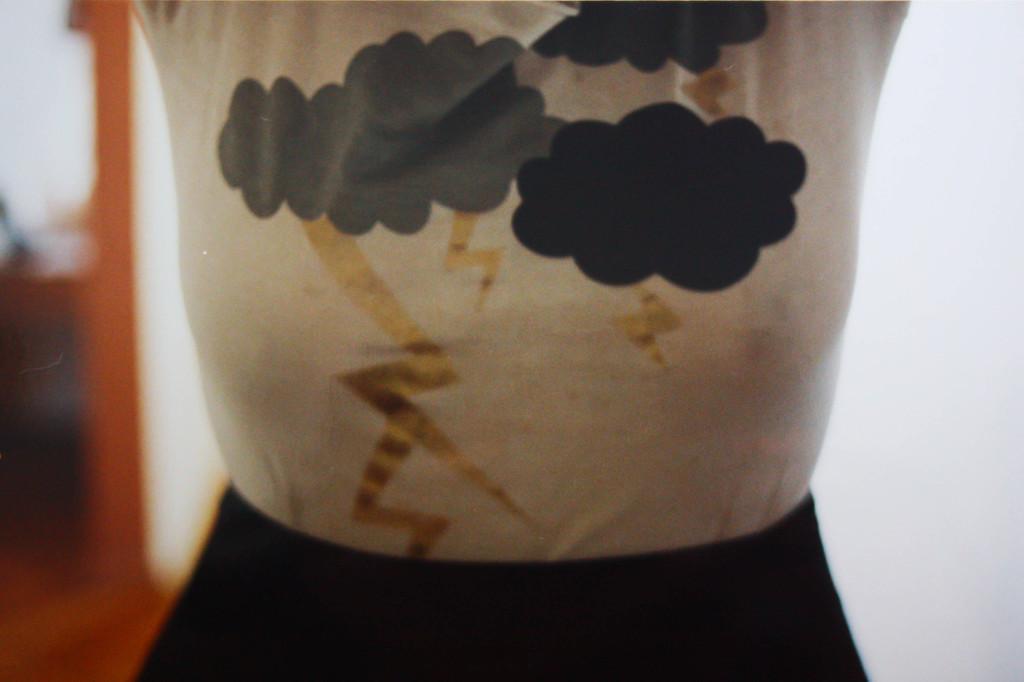Could you give a brief overview of what you see in this image? In this picture we can see clothes and in the background we can see some objects and it is blurry. 